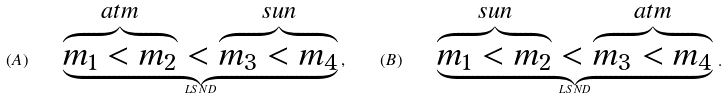Convert formula to latex. <formula><loc_0><loc_0><loc_500><loc_500>( A ) \quad \underbrace { \overbrace { m _ { 1 } < m _ { 2 } } ^ { a t m } < \overbrace { m _ { 3 } < m _ { 4 } } ^ { s u n } } _ { L S N D } \, , \quad ( B ) \quad \underbrace { \overbrace { m _ { 1 } < m _ { 2 } } ^ { s u n } < \overbrace { m _ { 3 } < m _ { 4 } } ^ { a t m } } _ { L S N D } \, .</formula> 